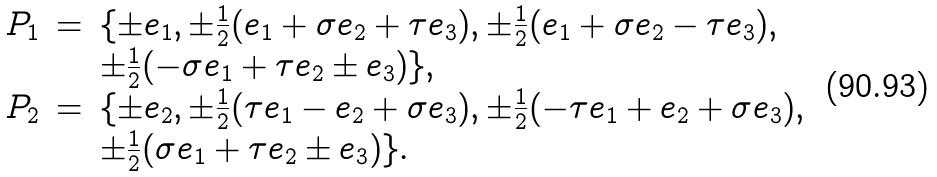Convert formula to latex. <formula><loc_0><loc_0><loc_500><loc_500>\begin{array} { l l l } P _ { 1 } & = & \{ \pm e _ { 1 } , \pm \frac { 1 } { 2 } ( e _ { 1 } + \sigma e _ { 2 } + \tau e _ { 3 } ) , \pm \frac { 1 } { 2 } ( e _ { 1 } + \sigma e _ { 2 } - \tau e _ { 3 } ) , \\ & & \pm \frac { 1 } { 2 } ( - \sigma e _ { 1 } + \tau e _ { 2 } \pm e _ { 3 } ) \} , \\ P _ { 2 } & = & \{ \pm e _ { 2 } , \pm \frac { 1 } { 2 } ( \tau e _ { 1 } - e _ { 2 } + \sigma e _ { 3 } ) , \pm \frac { 1 } { 2 } ( - \tau e _ { 1 } + e _ { 2 } + \sigma e _ { 3 } ) , \\ & & \pm \frac { 1 } { 2 } ( \sigma e _ { 1 } + \tau e _ { 2 } \pm e _ { 3 } ) \} . \end{array}</formula> 